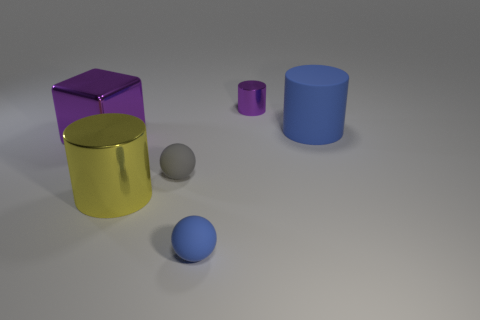What number of cubes are small gray matte objects or small metal things?
Your answer should be very brief. 0. How many matte things are behind the gray matte object and in front of the tiny gray object?
Keep it short and to the point. 0. Are there the same number of large blocks in front of the yellow metal cylinder and large yellow shiny cylinders on the left side of the blue rubber ball?
Give a very brief answer. No. There is a blue rubber object behind the small gray ball; is its shape the same as the yellow metal object?
Make the answer very short. Yes. The purple metallic object to the left of the shiny cylinder that is in front of the blue matte object on the right side of the small cylinder is what shape?
Offer a very short reply. Cube. There is a thing that is the same color as the large matte cylinder; what shape is it?
Your answer should be compact. Sphere. What material is the large object that is on the left side of the blue rubber sphere and behind the yellow metallic thing?
Provide a succinct answer. Metal. Is the number of small yellow rubber balls less than the number of gray spheres?
Make the answer very short. Yes. There is a tiny gray thing; is its shape the same as the purple object that is behind the large purple shiny block?
Make the answer very short. No. There is a blue thing that is in front of the yellow cylinder; is its size the same as the yellow metallic cylinder?
Ensure brevity in your answer.  No. 